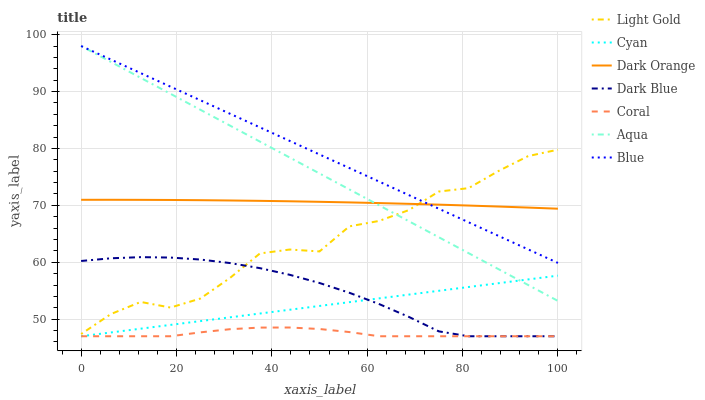Does Coral have the minimum area under the curve?
Answer yes or no. Yes. Does Blue have the maximum area under the curve?
Answer yes or no. Yes. Does Dark Orange have the minimum area under the curve?
Answer yes or no. No. Does Dark Orange have the maximum area under the curve?
Answer yes or no. No. Is Blue the smoothest?
Answer yes or no. Yes. Is Light Gold the roughest?
Answer yes or no. Yes. Is Dark Orange the smoothest?
Answer yes or no. No. Is Dark Orange the roughest?
Answer yes or no. No. Does Coral have the lowest value?
Answer yes or no. Yes. Does Dark Orange have the lowest value?
Answer yes or no. No. Does Aqua have the highest value?
Answer yes or no. Yes. Does Dark Orange have the highest value?
Answer yes or no. No. Is Coral less than Light Gold?
Answer yes or no. Yes. Is Light Gold greater than Cyan?
Answer yes or no. Yes. Does Coral intersect Cyan?
Answer yes or no. Yes. Is Coral less than Cyan?
Answer yes or no. No. Is Coral greater than Cyan?
Answer yes or no. No. Does Coral intersect Light Gold?
Answer yes or no. No. 